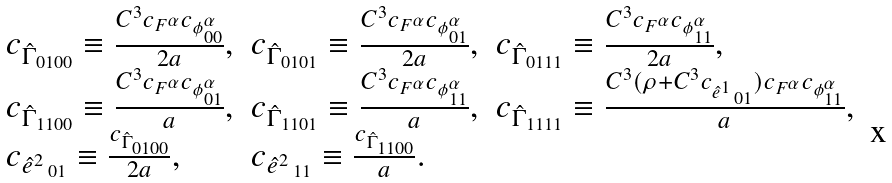Convert formula to latex. <formula><loc_0><loc_0><loc_500><loc_500>\begin{array} { l l l } c _ { \hat { \Gamma } _ { 0 1 0 0 } } \equiv \frac { C ^ { 3 } c _ { F ^ { \alpha } } c _ { \phi ^ { \alpha } _ { 0 0 } } } { 2 a } , & c _ { \hat { \Gamma } _ { 0 1 0 1 } } \equiv \frac { C ^ { 3 } c _ { F ^ { \alpha } } c _ { \phi ^ { \alpha } _ { 0 1 } } } { 2 a } , & c _ { \hat { \Gamma } _ { 0 1 1 1 } } \equiv \frac { C ^ { 3 } c _ { F ^ { \alpha } } c _ { \phi ^ { \alpha } _ { 1 1 } } } { 2 a } , \\ c _ { \hat { \Gamma } _ { 1 1 0 0 } } \equiv \frac { C ^ { 3 } c _ { F ^ { \alpha } } c _ { \phi ^ { \alpha } _ { 0 1 } } } { a } , & c _ { \hat { \Gamma } _ { 1 1 0 1 } } \equiv \frac { C ^ { 3 } c _ { F ^ { \alpha } } c _ { \phi ^ { \alpha } _ { 1 1 } } } { a } , & c _ { \hat { \Gamma } _ { 1 1 1 1 } } \equiv \frac { C ^ { 3 } ( \rho + C ^ { 3 } c _ { \hat { e } ^ { 1 } \, _ { 0 1 } } ) c _ { F ^ { \alpha } } c _ { \phi ^ { \alpha } _ { 1 1 } } } { a } , \\ c _ { \hat { e } ^ { 2 } \, _ { 0 1 } } \equiv \frac { c _ { \hat { \Gamma } _ { 0 1 0 0 } } } { 2 a } , & c _ { \hat { e } ^ { 2 } \, _ { 1 1 } } \equiv \frac { c _ { \hat { \Gamma } _ { 1 1 0 0 } } } { a } . \end{array}</formula> 